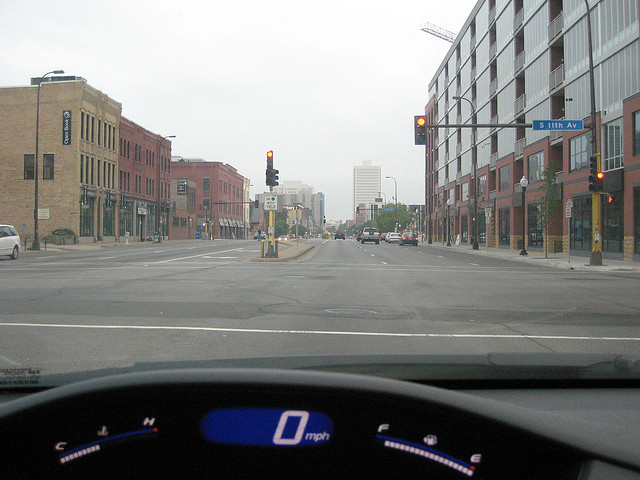Please identify all text content in this image. H C mph O Ave 11th S 